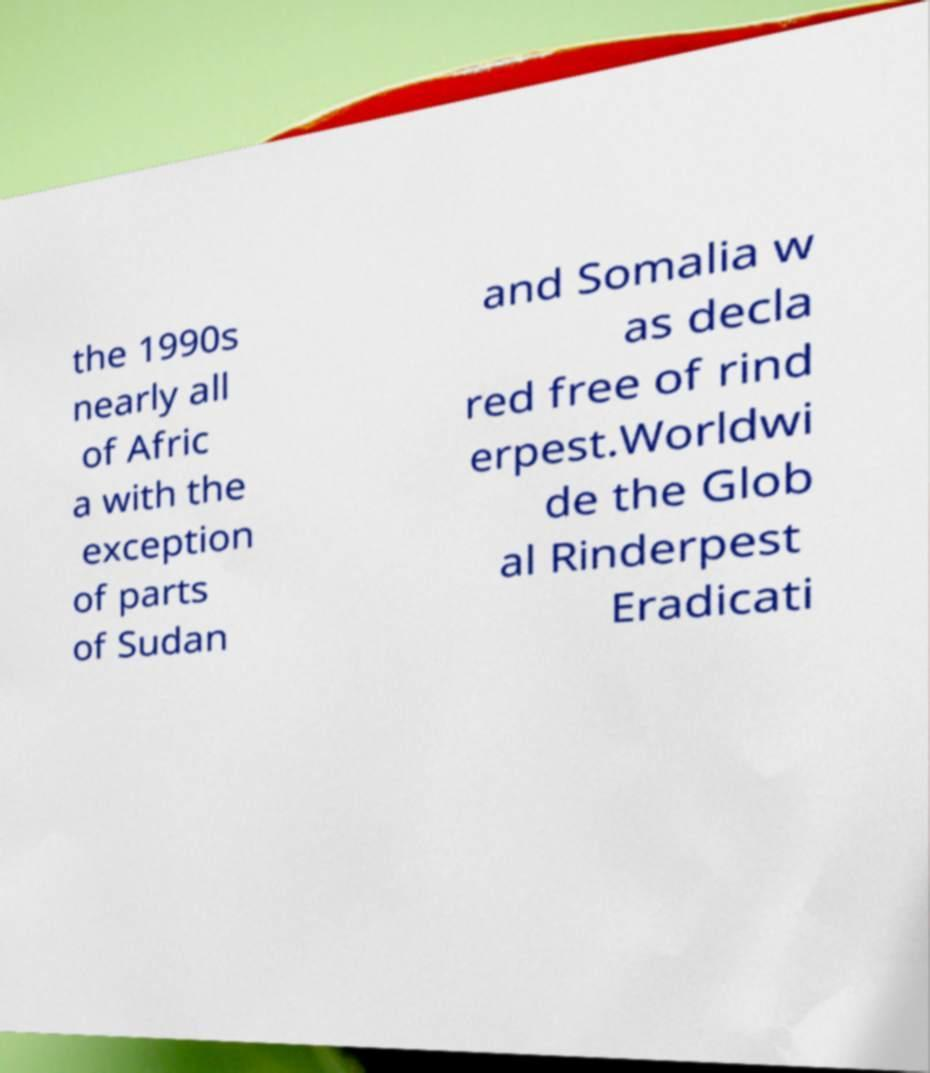For documentation purposes, I need the text within this image transcribed. Could you provide that? the 1990s nearly all of Afric a with the exception of parts of Sudan and Somalia w as decla red free of rind erpest.Worldwi de the Glob al Rinderpest Eradicati 